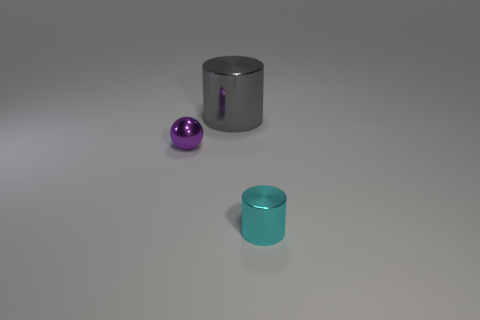Add 3 purple objects. How many objects exist? 6 Subtract all gray cylinders. How many cylinders are left? 1 Subtract 1 balls. How many balls are left? 0 Subtract all balls. How many objects are left? 2 Subtract all red spheres. How many blue cylinders are left? 0 Add 3 gray matte things. How many gray matte things exist? 3 Subtract 0 purple blocks. How many objects are left? 3 Subtract all cyan spheres. Subtract all brown cylinders. How many spheres are left? 1 Subtract all purple balls. Subtract all small metal cylinders. How many objects are left? 1 Add 1 gray shiny cylinders. How many gray shiny cylinders are left? 2 